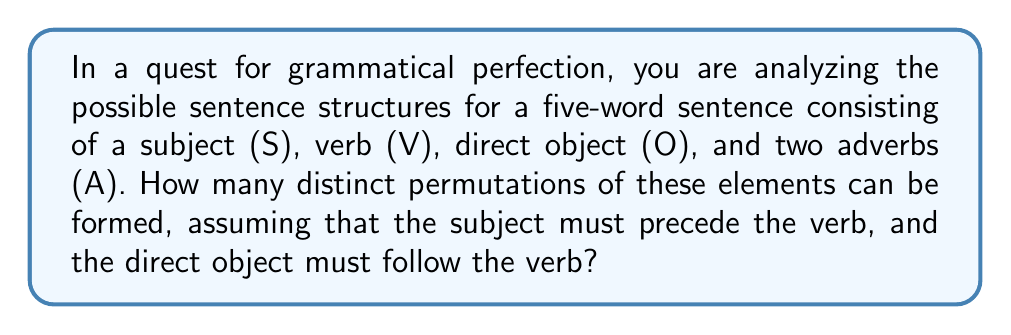Teach me how to tackle this problem. Let's approach this step-by-step:

1) We have 5 elements: S, V, O, and two A's.

2) The constraint that S must precede V and O must follow V reduces our problem to arranging 4 elements: (S+V), O, A1, and A2.

3) However, we need to consider that the two adverbs (A1 and A2) are interchangeable, which affects our calculation.

4) To solve this, we'll use the formula for permutations with repetition:

   $$ P = \frac{n!}{n_1! \cdot n_2! \cdot ... \cdot n_k!} $$

   Where $n$ is the total number of elements, and $n_1, n_2, ..., n_k$ are the numbers of each repeated element.

5) In our case:
   $n = 4$ (total elements: SV, O, A1, A2)
   $n_1 = 2$ (2 adverbs are repeated)

6) Plugging into our formula:

   $$ P = \frac{4!}{2!} $$

7) Calculating:

   $$ P = \frac{24}{2} = 12 $$

Therefore, there are 12 distinct permutations of these sentence elements.
Answer: 12 permutations 